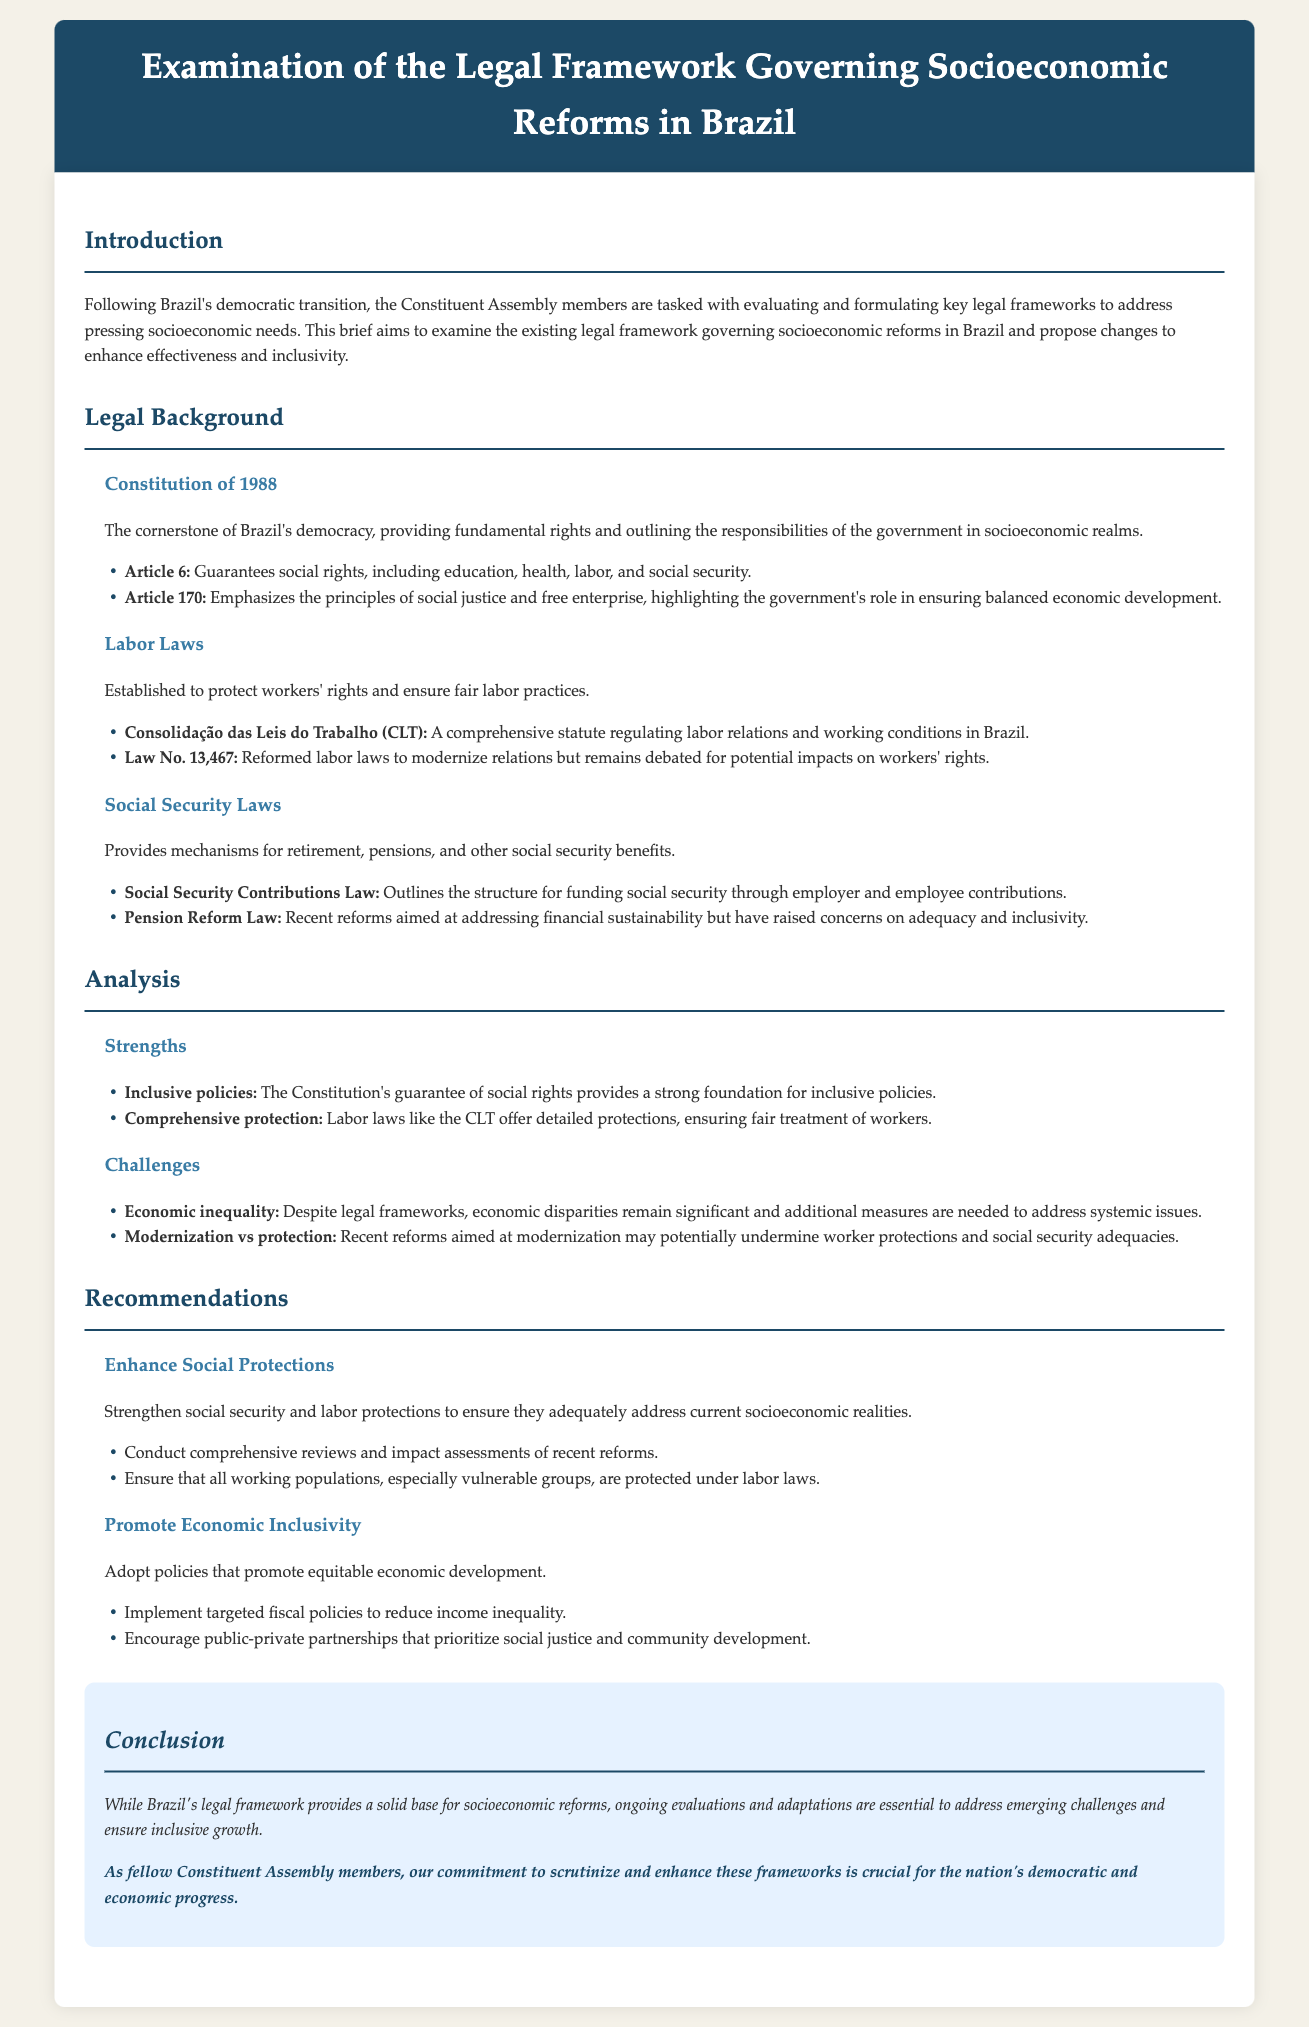What is the cornerstone of Brazil's democracy? The Constitution of 1988 is referenced as the cornerstone of Brazil's democracy, providing fundamental rights and outlining the responsibilities of the government in socioeconomic realms.
Answer: Constitution of 1988 Which article guarantees social rights in Brazil? Article 6 of the Constitution guarantees social rights, including education, health, labor, and social security.
Answer: Article 6 What law regulates labor relations in Brazil? The Consolidação das Leis do Trabalho (CLT) is presented as the comprehensive statute regulating labor relations and working conditions in Brazil.
Answer: CLT What is one of the strengths mentioned in the analysis? The analysis highlights that the Constitution's guarantee of social rights provides a strong foundation for inclusive policies.
Answer: Inclusive policies What is a proposed recommendation related to social protections? The recommendation suggests strengthening social security and labor protections to ensure they adequately address current socioeconomic realities.
Answer: Enhance Social Protections 